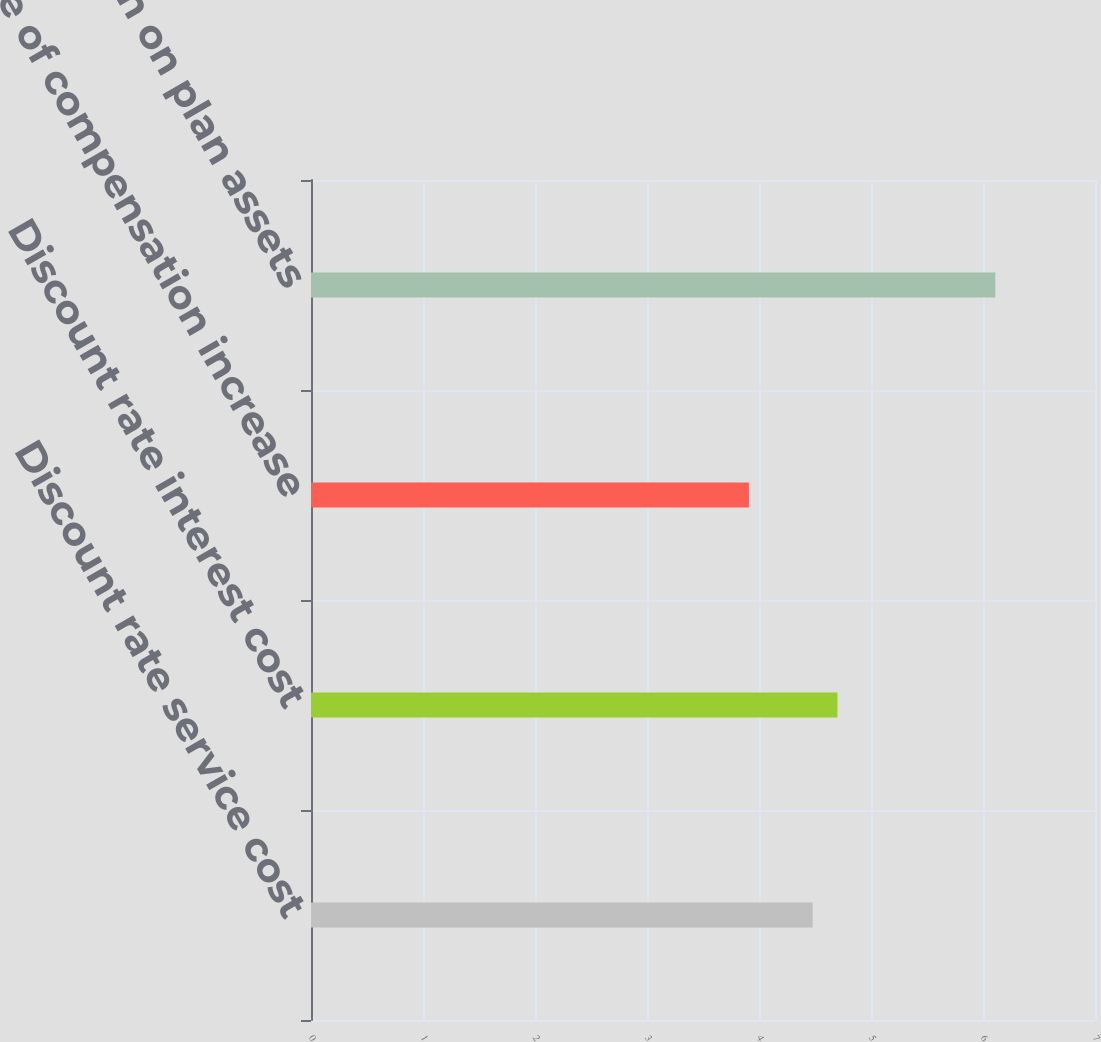Convert chart. <chart><loc_0><loc_0><loc_500><loc_500><bar_chart><fcel>Discount rate service cost<fcel>Discount rate interest cost<fcel>Rate of compensation increase<fcel>Expected return on plan assets<nl><fcel>4.48<fcel>4.7<fcel>3.91<fcel>6.11<nl></chart> 